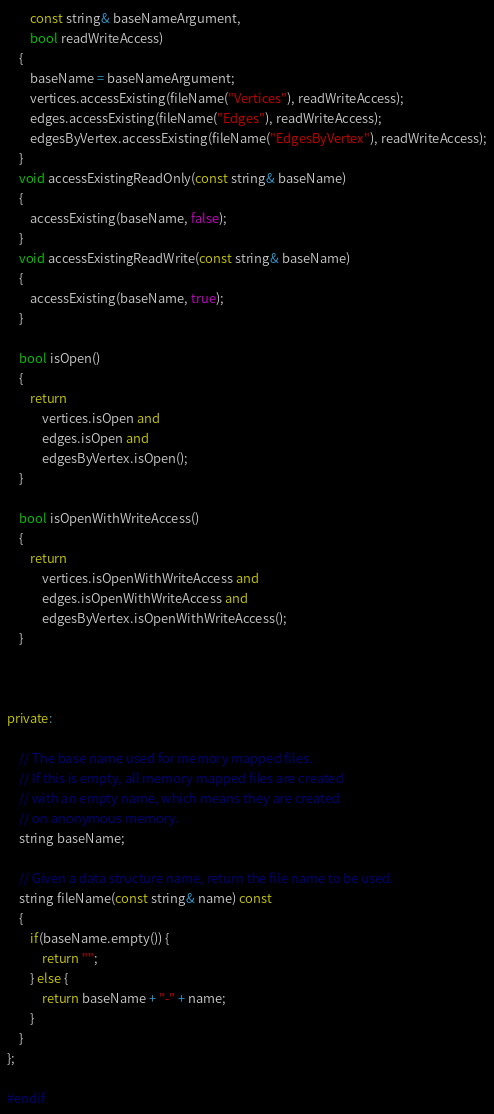<code> <loc_0><loc_0><loc_500><loc_500><_C++_>        const string& baseNameArgument,
        bool readWriteAccess)
    {
        baseName = baseNameArgument;
        vertices.accessExisting(fileName("Vertices"), readWriteAccess);
        edges.accessExisting(fileName("Edges"), readWriteAccess);
        edgesByVertex.accessExisting(fileName("EdgesByVertex"), readWriteAccess);
    }
    void accessExistingReadOnly(const string& baseName)
    {
        accessExisting(baseName, false);
    }
    void accessExistingReadWrite(const string& baseName)
    {
        accessExisting(baseName, true);
    }

    bool isOpen()
    {
        return
            vertices.isOpen and
            edges.isOpen and
            edgesByVertex.isOpen();
    }

    bool isOpenWithWriteAccess()
    {
        return
            vertices.isOpenWithWriteAccess and
            edges.isOpenWithWriteAccess and
            edgesByVertex.isOpenWithWriteAccess();
    }



private:

    // The base name used for memory mapped files.
    // If this is empty, all memory mapped files are created
    // with an empty name, which means they are created
    // on anonymous memory.
    string baseName;

    // Given a data structure name, return the file name to be used.
    string fileName(const string& name) const
    {
        if(baseName.empty()) {
            return "";
        } else {
            return baseName + "-" + name;
        }
    }
};

#endif


</code> 